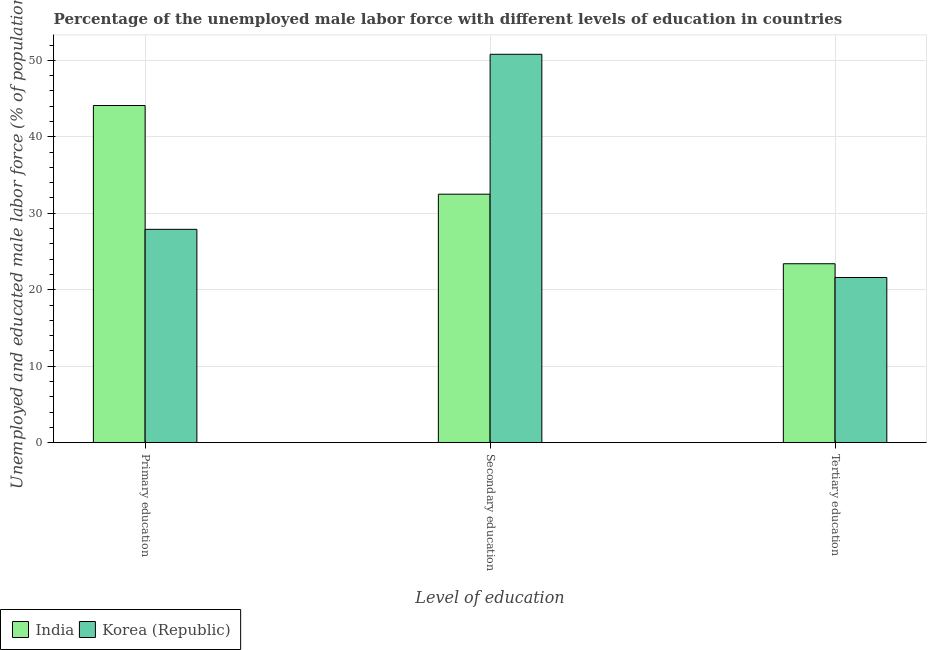How many different coloured bars are there?
Ensure brevity in your answer.  2. How many groups of bars are there?
Give a very brief answer. 3. Are the number of bars per tick equal to the number of legend labels?
Ensure brevity in your answer.  Yes. Are the number of bars on each tick of the X-axis equal?
Your answer should be very brief. Yes. How many bars are there on the 2nd tick from the right?
Keep it short and to the point. 2. What is the label of the 3rd group of bars from the left?
Your answer should be compact. Tertiary education. What is the percentage of male labor force who received tertiary education in India?
Give a very brief answer. 23.4. Across all countries, what is the maximum percentage of male labor force who received secondary education?
Your response must be concise. 50.8. Across all countries, what is the minimum percentage of male labor force who received primary education?
Your answer should be very brief. 27.9. In which country was the percentage of male labor force who received primary education minimum?
Your answer should be very brief. Korea (Republic). What is the total percentage of male labor force who received primary education in the graph?
Offer a very short reply. 72. What is the difference between the percentage of male labor force who received tertiary education in Korea (Republic) and that in India?
Give a very brief answer. -1.8. What is the difference between the percentage of male labor force who received primary education in India and the percentage of male labor force who received secondary education in Korea (Republic)?
Your response must be concise. -6.7. What is the average percentage of male labor force who received primary education per country?
Keep it short and to the point. 36. What is the difference between the percentage of male labor force who received secondary education and percentage of male labor force who received primary education in India?
Provide a succinct answer. -11.6. What is the ratio of the percentage of male labor force who received primary education in India to that in Korea (Republic)?
Your answer should be very brief. 1.58. Is the percentage of male labor force who received secondary education in Korea (Republic) less than that in India?
Provide a succinct answer. No. What is the difference between the highest and the second highest percentage of male labor force who received tertiary education?
Keep it short and to the point. 1.8. What is the difference between the highest and the lowest percentage of male labor force who received tertiary education?
Provide a short and direct response. 1.8. In how many countries, is the percentage of male labor force who received secondary education greater than the average percentage of male labor force who received secondary education taken over all countries?
Give a very brief answer. 1. Is the sum of the percentage of male labor force who received primary education in India and Korea (Republic) greater than the maximum percentage of male labor force who received tertiary education across all countries?
Make the answer very short. Yes. What does the 2nd bar from the left in Tertiary education represents?
Ensure brevity in your answer.  Korea (Republic). What does the 1st bar from the right in Primary education represents?
Make the answer very short. Korea (Republic). How many bars are there?
Your response must be concise. 6. How many countries are there in the graph?
Your answer should be very brief. 2. Where does the legend appear in the graph?
Keep it short and to the point. Bottom left. What is the title of the graph?
Provide a short and direct response. Percentage of the unemployed male labor force with different levels of education in countries. What is the label or title of the X-axis?
Keep it short and to the point. Level of education. What is the label or title of the Y-axis?
Ensure brevity in your answer.  Unemployed and educated male labor force (% of population). What is the Unemployed and educated male labor force (% of population) of India in Primary education?
Offer a very short reply. 44.1. What is the Unemployed and educated male labor force (% of population) in Korea (Republic) in Primary education?
Offer a terse response. 27.9. What is the Unemployed and educated male labor force (% of population) in India in Secondary education?
Your answer should be compact. 32.5. What is the Unemployed and educated male labor force (% of population) of Korea (Republic) in Secondary education?
Provide a succinct answer. 50.8. What is the Unemployed and educated male labor force (% of population) in India in Tertiary education?
Offer a very short reply. 23.4. What is the Unemployed and educated male labor force (% of population) in Korea (Republic) in Tertiary education?
Give a very brief answer. 21.6. Across all Level of education, what is the maximum Unemployed and educated male labor force (% of population) of India?
Give a very brief answer. 44.1. Across all Level of education, what is the maximum Unemployed and educated male labor force (% of population) in Korea (Republic)?
Offer a terse response. 50.8. Across all Level of education, what is the minimum Unemployed and educated male labor force (% of population) in India?
Provide a short and direct response. 23.4. Across all Level of education, what is the minimum Unemployed and educated male labor force (% of population) of Korea (Republic)?
Offer a very short reply. 21.6. What is the total Unemployed and educated male labor force (% of population) in India in the graph?
Offer a very short reply. 100. What is the total Unemployed and educated male labor force (% of population) in Korea (Republic) in the graph?
Your answer should be very brief. 100.3. What is the difference between the Unemployed and educated male labor force (% of population) in India in Primary education and that in Secondary education?
Provide a succinct answer. 11.6. What is the difference between the Unemployed and educated male labor force (% of population) of Korea (Republic) in Primary education and that in Secondary education?
Make the answer very short. -22.9. What is the difference between the Unemployed and educated male labor force (% of population) of India in Primary education and that in Tertiary education?
Your answer should be very brief. 20.7. What is the difference between the Unemployed and educated male labor force (% of population) in Korea (Republic) in Secondary education and that in Tertiary education?
Offer a terse response. 29.2. What is the difference between the Unemployed and educated male labor force (% of population) in India in Primary education and the Unemployed and educated male labor force (% of population) in Korea (Republic) in Tertiary education?
Offer a terse response. 22.5. What is the average Unemployed and educated male labor force (% of population) of India per Level of education?
Offer a terse response. 33.33. What is the average Unemployed and educated male labor force (% of population) in Korea (Republic) per Level of education?
Offer a terse response. 33.43. What is the difference between the Unemployed and educated male labor force (% of population) in India and Unemployed and educated male labor force (% of population) in Korea (Republic) in Primary education?
Offer a very short reply. 16.2. What is the difference between the Unemployed and educated male labor force (% of population) of India and Unemployed and educated male labor force (% of population) of Korea (Republic) in Secondary education?
Provide a succinct answer. -18.3. What is the ratio of the Unemployed and educated male labor force (% of population) of India in Primary education to that in Secondary education?
Provide a short and direct response. 1.36. What is the ratio of the Unemployed and educated male labor force (% of population) of Korea (Republic) in Primary education to that in Secondary education?
Provide a short and direct response. 0.55. What is the ratio of the Unemployed and educated male labor force (% of population) of India in Primary education to that in Tertiary education?
Provide a succinct answer. 1.88. What is the ratio of the Unemployed and educated male labor force (% of population) in Korea (Republic) in Primary education to that in Tertiary education?
Make the answer very short. 1.29. What is the ratio of the Unemployed and educated male labor force (% of population) of India in Secondary education to that in Tertiary education?
Give a very brief answer. 1.39. What is the ratio of the Unemployed and educated male labor force (% of population) in Korea (Republic) in Secondary education to that in Tertiary education?
Provide a short and direct response. 2.35. What is the difference between the highest and the second highest Unemployed and educated male labor force (% of population) in India?
Provide a succinct answer. 11.6. What is the difference between the highest and the second highest Unemployed and educated male labor force (% of population) in Korea (Republic)?
Your response must be concise. 22.9. What is the difference between the highest and the lowest Unemployed and educated male labor force (% of population) in India?
Make the answer very short. 20.7. What is the difference between the highest and the lowest Unemployed and educated male labor force (% of population) of Korea (Republic)?
Keep it short and to the point. 29.2. 